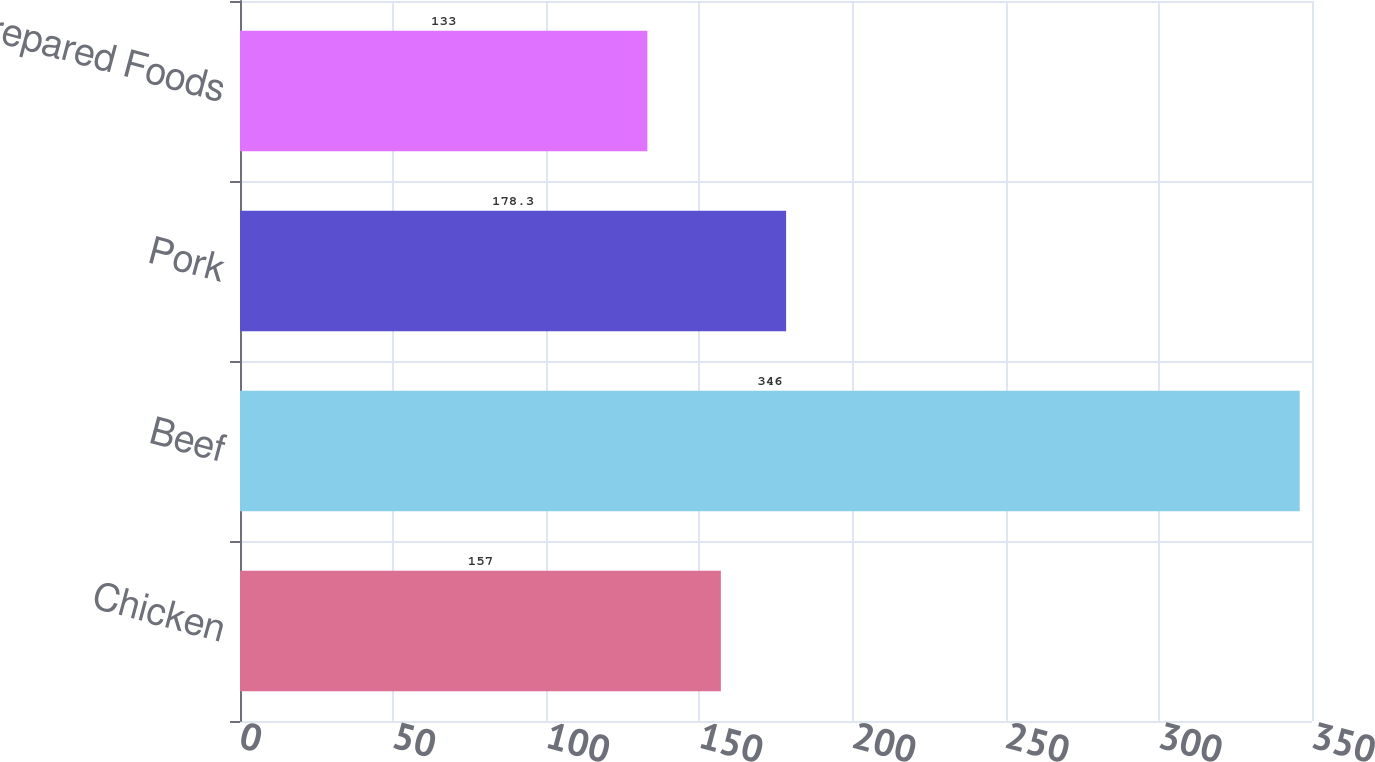<chart> <loc_0><loc_0><loc_500><loc_500><bar_chart><fcel>Chicken<fcel>Beef<fcel>Pork<fcel>Prepared Foods<nl><fcel>157<fcel>346<fcel>178.3<fcel>133<nl></chart> 